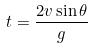Convert formula to latex. <formula><loc_0><loc_0><loc_500><loc_500>t = \frac { 2 v \sin \theta } { g }</formula> 